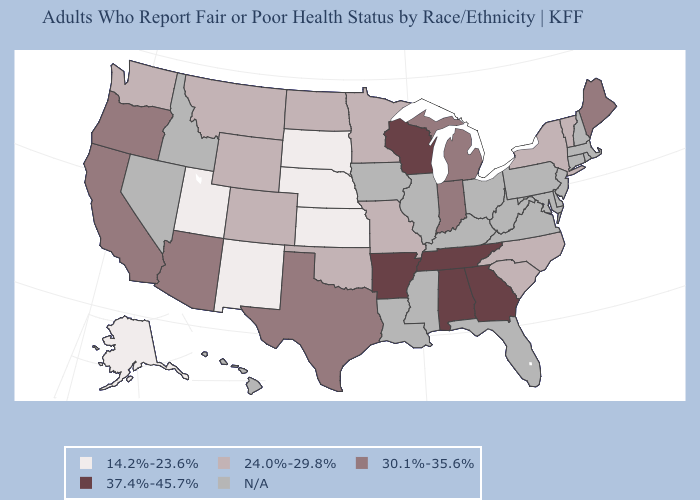What is the value of Nebraska?
Quick response, please. 14.2%-23.6%. Among the states that border Washington , which have the highest value?
Answer briefly. Oregon. Which states have the lowest value in the Northeast?
Concise answer only. New York, Vermont. Among the states that border North Dakota , which have the lowest value?
Answer briefly. South Dakota. Name the states that have a value in the range N/A?
Be succinct. Connecticut, Delaware, Florida, Hawaii, Idaho, Illinois, Iowa, Kentucky, Louisiana, Maryland, Massachusetts, Mississippi, Nevada, New Hampshire, New Jersey, Ohio, Pennsylvania, Rhode Island, Virginia, West Virginia. What is the value of Tennessee?
Keep it brief. 37.4%-45.7%. Name the states that have a value in the range 24.0%-29.8%?
Quick response, please. Colorado, Minnesota, Missouri, Montana, New York, North Carolina, North Dakota, Oklahoma, South Carolina, Vermont, Washington, Wyoming. Name the states that have a value in the range 30.1%-35.6%?
Write a very short answer. Arizona, California, Indiana, Maine, Michigan, Oregon, Texas. Among the states that border Kentucky , which have the lowest value?
Short answer required. Missouri. Which states have the lowest value in the USA?
Be succinct. Alaska, Kansas, Nebraska, New Mexico, South Dakota, Utah. What is the lowest value in the USA?
Concise answer only. 14.2%-23.6%. What is the value of Indiana?
Concise answer only. 30.1%-35.6%. What is the lowest value in the South?
Keep it brief. 24.0%-29.8%. 